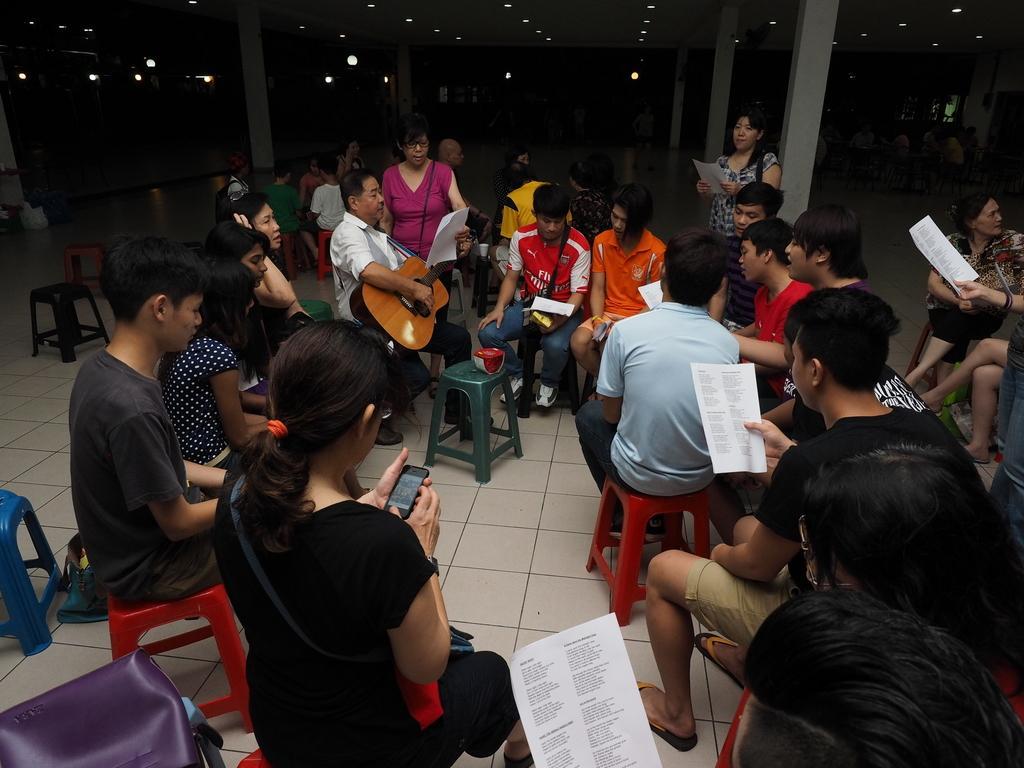Describe this image in one or two sentences. In this picture we can see a group of people where some are sitting on stool and some are standing and some are holding mobiles, guitars, papers in their hands and in background we can see pillar, lights and it is dark. 